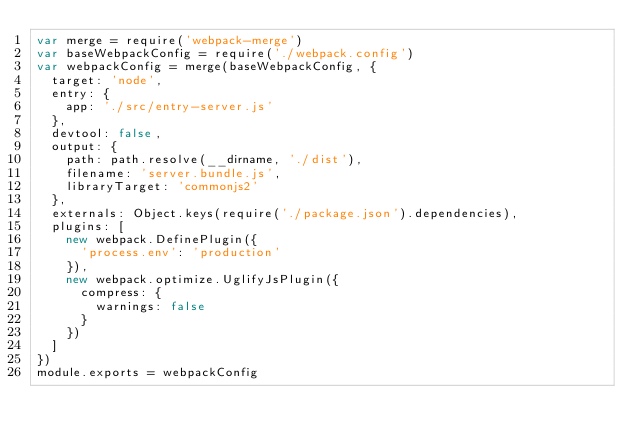<code> <loc_0><loc_0><loc_500><loc_500><_JavaScript_>var merge = require('webpack-merge')
var baseWebpackConfig = require('./webpack.config')
var webpackConfig = merge(baseWebpackConfig, {
  target: 'node',
  entry: {
    app: './src/entry-server.js'
  },
  devtool: false,
  output: {
    path: path.resolve(__dirname, './dist'),
    filename: 'server.bundle.js',
    libraryTarget: 'commonjs2'
  },
  externals: Object.keys(require('./package.json').dependencies),
  plugins: [
    new webpack.DefinePlugin({
      'process.env': 'production'
    }),
    new webpack.optimize.UglifyJsPlugin({
      compress: {
        warnings: false
      }
    })
  ]
})
module.exports = webpackConfig</code> 